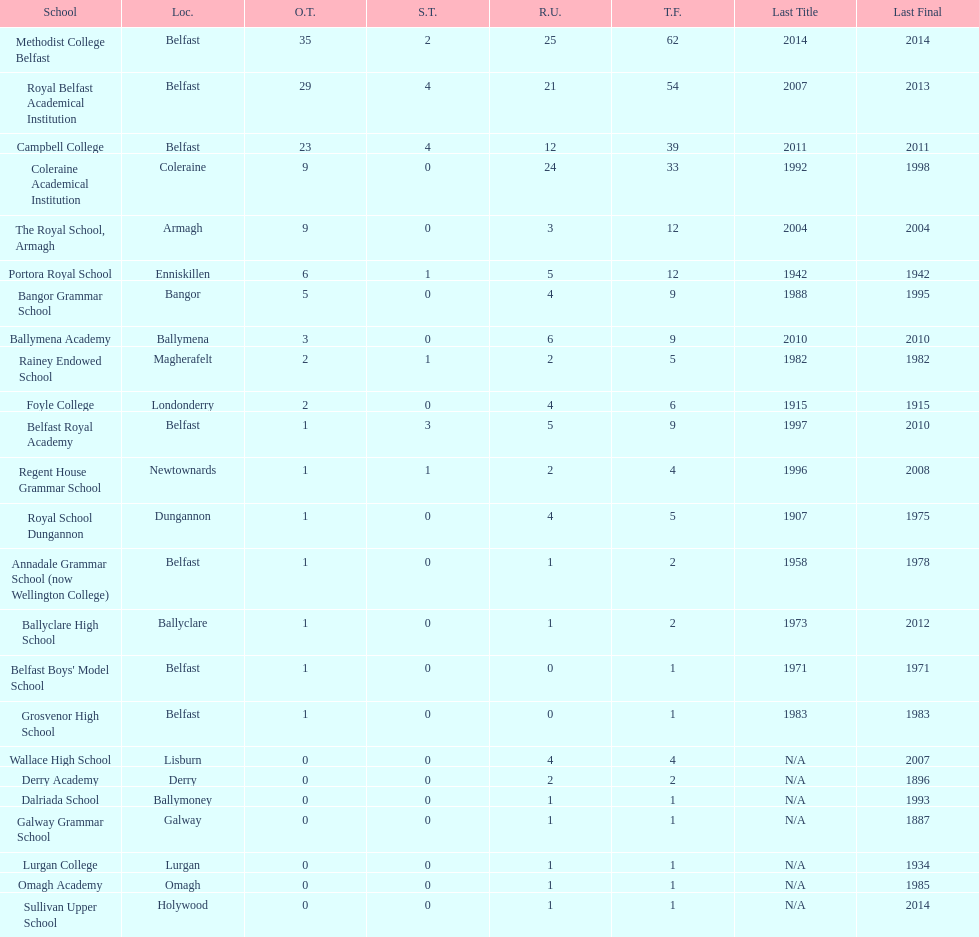Which school has the same number of outright titles as the coleraine academical institution? The Royal School, Armagh. 